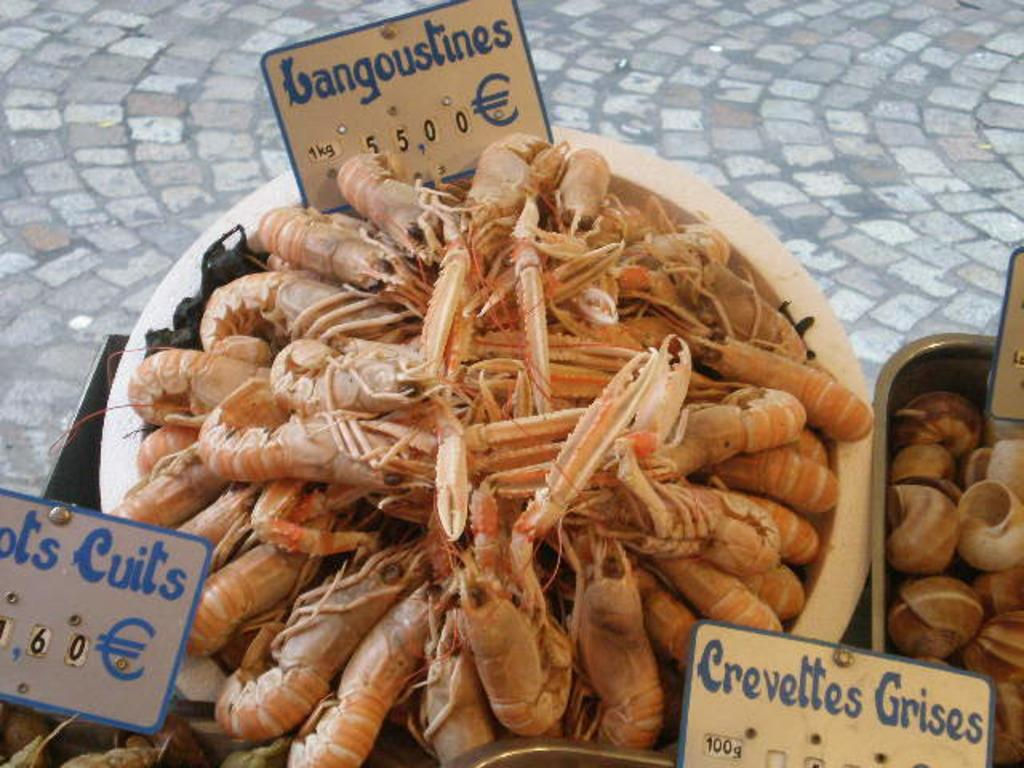What type of seafood is present in the image? There are dry shrimps in the image. What other marine creatures are visible in the image? There are cells of snails in the image. How are the dry shrimps and cells of snails arranged in the image? They are arranged in bowls in the image. What can be seen on the table in the image? There are cards on the table in the image. What type of surface is visible at the bottom of the image? There is a floor visible in the image. Can you tell me how many men are holding twigs in the image? There are no men or twigs present in the image. What do the people in the image believe about the snails? The image does not provide any information about the beliefs of the people regarding the snails. 